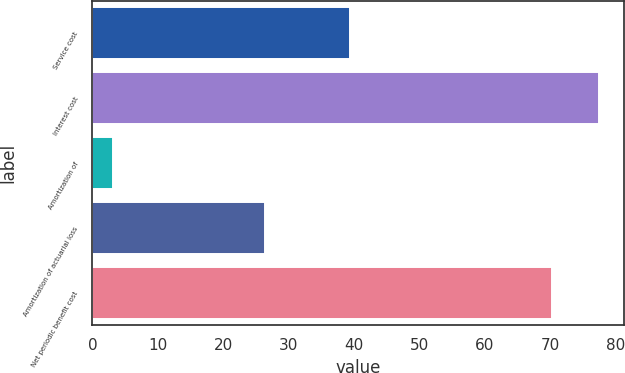Convert chart to OTSL. <chart><loc_0><loc_0><loc_500><loc_500><bar_chart><fcel>Service cost<fcel>Interest cost<fcel>Amortization of<fcel>Amortization of actuarial loss<fcel>Net periodic benefit cost<nl><fcel>39.4<fcel>77.43<fcel>3.2<fcel>26.4<fcel>70.3<nl></chart> 